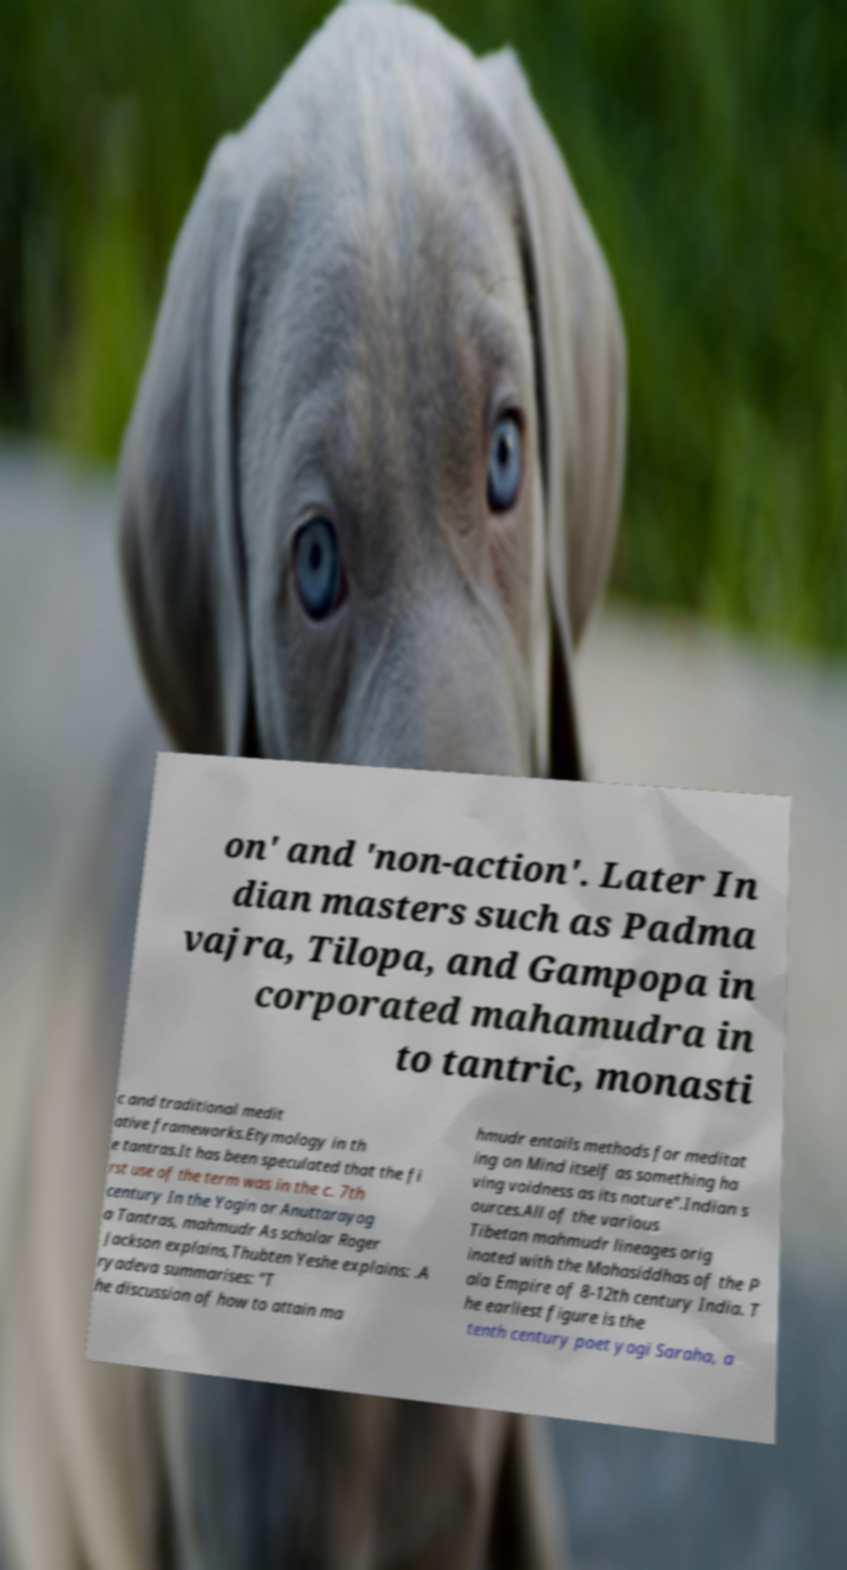Can you read and provide the text displayed in the image?This photo seems to have some interesting text. Can you extract and type it out for me? on' and 'non-action'. Later In dian masters such as Padma vajra, Tilopa, and Gampopa in corporated mahamudra in to tantric, monasti c and traditional medit ative frameworks.Etymology in th e tantras.It has been speculated that the fi rst use of the term was in the c. 7th century In the Yogin or Anuttarayog a Tantras, mahmudr As scholar Roger Jackson explains,Thubten Yeshe explains: .A ryadeva summarises: "T he discussion of how to attain ma hmudr entails methods for meditat ing on Mind itself as something ha ving voidness as its nature".Indian s ources.All of the various Tibetan mahmudr lineages orig inated with the Mahasiddhas of the P ala Empire of 8-12th century India. T he earliest figure is the tenth century poet yogi Saraha, a 